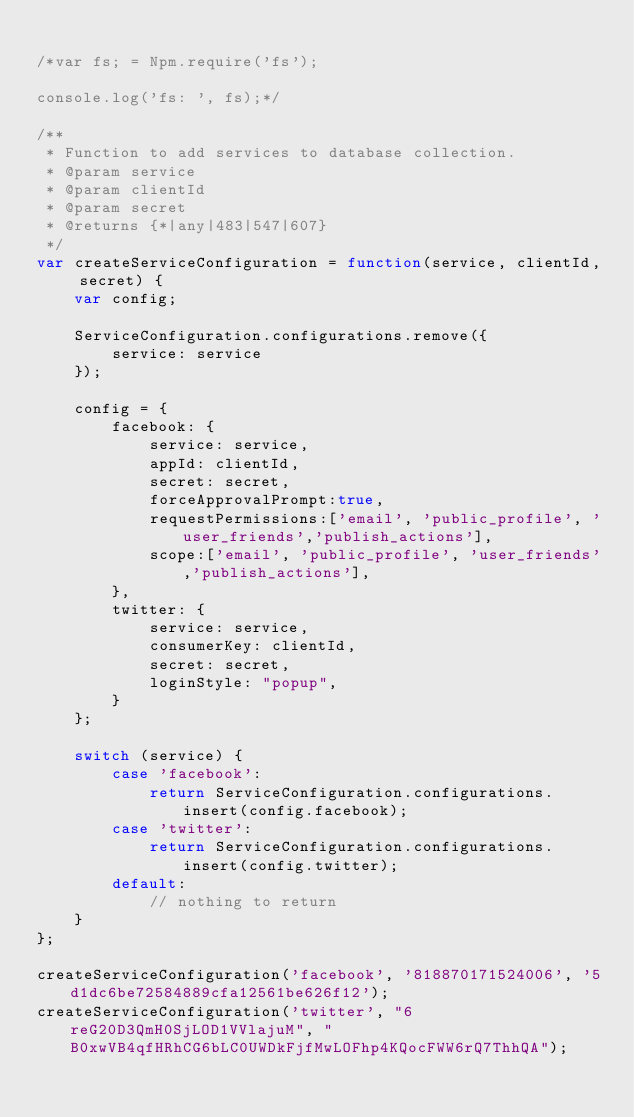Convert code to text. <code><loc_0><loc_0><loc_500><loc_500><_JavaScript_>
/*var fs; = Npm.require('fs');

console.log('fs: ', fs);*/

/**
 * Function to add services to database collection.
 * @param service
 * @param clientId
 * @param secret
 * @returns {*|any|483|547|607}
 */
var createServiceConfiguration = function(service, clientId, secret) {
    var config;

    ServiceConfiguration.configurations.remove({
        service: service
    });

    config = {
        facebook: {
            service: service,
            appId: clientId,
            secret: secret,
            forceApprovalPrompt:true,
            requestPermissions:['email', 'public_profile', 'user_friends','publish_actions'],
            scope:['email', 'public_profile', 'user_friends','publish_actions'],
        },
        twitter: {
            service: service,
            consumerKey: clientId,
            secret: secret,
            loginStyle: "popup",
        }
    };

    switch (service) {
        case 'facebook':
            return ServiceConfiguration.configurations.insert(config.facebook);
        case 'twitter':
            return ServiceConfiguration.configurations.insert(config.twitter);
        default:
            // nothing to return
    }
};

createServiceConfiguration('facebook', '818870171524006', '5d1dc6be72584889cfa12561be626f12');
createServiceConfiguration('twitter', "6reG20D3QmH0SjLOD1VVlajuM", "B0xwVB4qfHRhCG6bLC0UWDkFjfMwLOFhp4KQocFWW6rQ7ThhQA");</code> 